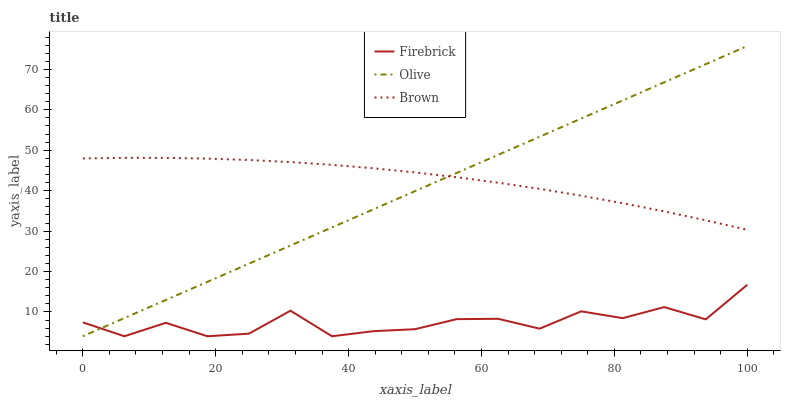Does Firebrick have the minimum area under the curve?
Answer yes or no. Yes. Does Brown have the maximum area under the curve?
Answer yes or no. Yes. Does Brown have the minimum area under the curve?
Answer yes or no. No. Does Firebrick have the maximum area under the curve?
Answer yes or no. No. Is Olive the smoothest?
Answer yes or no. Yes. Is Firebrick the roughest?
Answer yes or no. Yes. Is Brown the smoothest?
Answer yes or no. No. Is Brown the roughest?
Answer yes or no. No. Does Olive have the lowest value?
Answer yes or no. Yes. Does Brown have the lowest value?
Answer yes or no. No. Does Olive have the highest value?
Answer yes or no. Yes. Does Brown have the highest value?
Answer yes or no. No. Is Firebrick less than Brown?
Answer yes or no. Yes. Is Brown greater than Firebrick?
Answer yes or no. Yes. Does Olive intersect Firebrick?
Answer yes or no. Yes. Is Olive less than Firebrick?
Answer yes or no. No. Is Olive greater than Firebrick?
Answer yes or no. No. Does Firebrick intersect Brown?
Answer yes or no. No. 